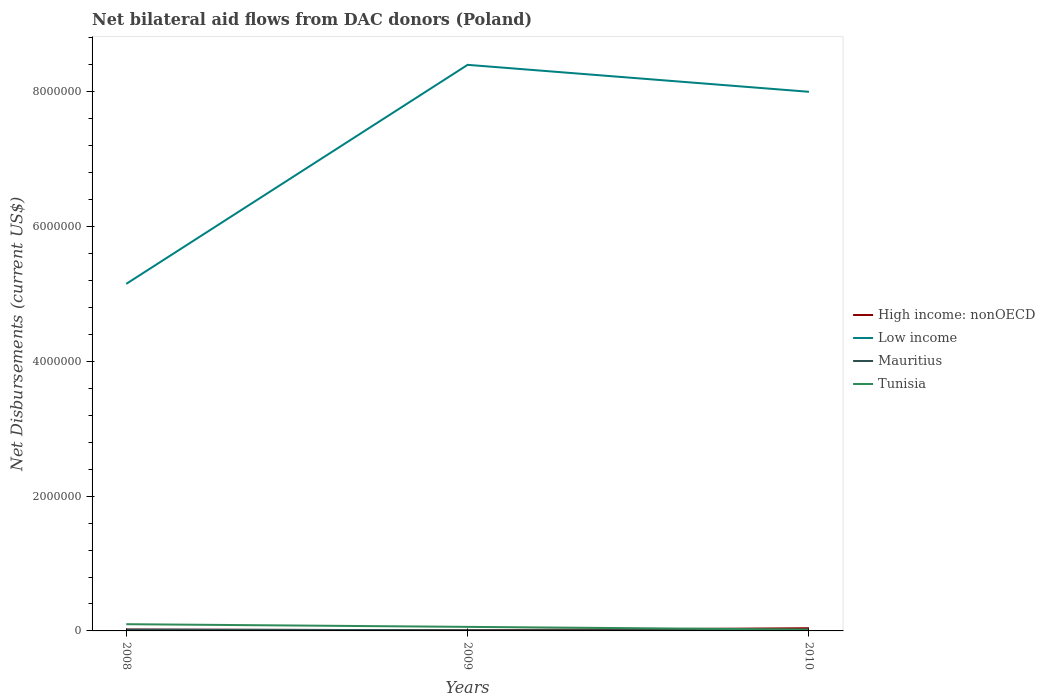Is the number of lines equal to the number of legend labels?
Provide a succinct answer. Yes. Across all years, what is the maximum net bilateral aid flows in Tunisia?
Your answer should be very brief. 2.00e+04. In which year was the net bilateral aid flows in Mauritius maximum?
Make the answer very short. 2009. What is the difference between the highest and the lowest net bilateral aid flows in Low income?
Offer a very short reply. 2. How many lines are there?
Provide a short and direct response. 4. How many years are there in the graph?
Provide a short and direct response. 3. What is the difference between two consecutive major ticks on the Y-axis?
Offer a terse response. 2.00e+06. Are the values on the major ticks of Y-axis written in scientific E-notation?
Give a very brief answer. No. Does the graph contain any zero values?
Your answer should be compact. No. Where does the legend appear in the graph?
Your answer should be very brief. Center right. What is the title of the graph?
Your answer should be compact. Net bilateral aid flows from DAC donors (Poland). What is the label or title of the Y-axis?
Your answer should be compact. Net Disbursements (current US$). What is the Net Disbursements (current US$) of Low income in 2008?
Offer a very short reply. 5.15e+06. What is the Net Disbursements (current US$) in Mauritius in 2008?
Offer a terse response. 2.00e+04. What is the Net Disbursements (current US$) of Tunisia in 2008?
Give a very brief answer. 1.00e+05. What is the Net Disbursements (current US$) in Low income in 2009?
Offer a terse response. 8.40e+06. What is the Net Disbursements (current US$) in Mauritius in 2009?
Provide a short and direct response. 10000. What is the Net Disbursements (current US$) of Tunisia in 2009?
Give a very brief answer. 6.00e+04. What is the Net Disbursements (current US$) in Low income in 2010?
Provide a short and direct response. 8.00e+06. Across all years, what is the maximum Net Disbursements (current US$) in High income: nonOECD?
Your answer should be compact. 4.00e+04. Across all years, what is the maximum Net Disbursements (current US$) in Low income?
Your answer should be very brief. 8.40e+06. Across all years, what is the maximum Net Disbursements (current US$) in Tunisia?
Make the answer very short. 1.00e+05. Across all years, what is the minimum Net Disbursements (current US$) of Low income?
Keep it short and to the point. 5.15e+06. Across all years, what is the minimum Net Disbursements (current US$) of Mauritius?
Your response must be concise. 10000. Across all years, what is the minimum Net Disbursements (current US$) in Tunisia?
Keep it short and to the point. 2.00e+04. What is the total Net Disbursements (current US$) in Low income in the graph?
Provide a succinct answer. 2.16e+07. What is the total Net Disbursements (current US$) of Mauritius in the graph?
Make the answer very short. 4.00e+04. What is the total Net Disbursements (current US$) of Tunisia in the graph?
Make the answer very short. 1.80e+05. What is the difference between the Net Disbursements (current US$) in High income: nonOECD in 2008 and that in 2009?
Offer a terse response. 10000. What is the difference between the Net Disbursements (current US$) in Low income in 2008 and that in 2009?
Provide a succinct answer. -3.25e+06. What is the difference between the Net Disbursements (current US$) of Mauritius in 2008 and that in 2009?
Keep it short and to the point. 10000. What is the difference between the Net Disbursements (current US$) of Tunisia in 2008 and that in 2009?
Ensure brevity in your answer.  4.00e+04. What is the difference between the Net Disbursements (current US$) of Low income in 2008 and that in 2010?
Make the answer very short. -2.85e+06. What is the difference between the Net Disbursements (current US$) in Low income in 2009 and that in 2010?
Your response must be concise. 4.00e+05. What is the difference between the Net Disbursements (current US$) of High income: nonOECD in 2008 and the Net Disbursements (current US$) of Low income in 2009?
Make the answer very short. -8.38e+06. What is the difference between the Net Disbursements (current US$) of High income: nonOECD in 2008 and the Net Disbursements (current US$) of Mauritius in 2009?
Offer a terse response. 10000. What is the difference between the Net Disbursements (current US$) of High income: nonOECD in 2008 and the Net Disbursements (current US$) of Tunisia in 2009?
Offer a terse response. -4.00e+04. What is the difference between the Net Disbursements (current US$) in Low income in 2008 and the Net Disbursements (current US$) in Mauritius in 2009?
Ensure brevity in your answer.  5.14e+06. What is the difference between the Net Disbursements (current US$) in Low income in 2008 and the Net Disbursements (current US$) in Tunisia in 2009?
Offer a terse response. 5.09e+06. What is the difference between the Net Disbursements (current US$) in High income: nonOECD in 2008 and the Net Disbursements (current US$) in Low income in 2010?
Make the answer very short. -7.98e+06. What is the difference between the Net Disbursements (current US$) in High income: nonOECD in 2008 and the Net Disbursements (current US$) in Mauritius in 2010?
Give a very brief answer. 10000. What is the difference between the Net Disbursements (current US$) of High income: nonOECD in 2008 and the Net Disbursements (current US$) of Tunisia in 2010?
Make the answer very short. 0. What is the difference between the Net Disbursements (current US$) of Low income in 2008 and the Net Disbursements (current US$) of Mauritius in 2010?
Your response must be concise. 5.14e+06. What is the difference between the Net Disbursements (current US$) of Low income in 2008 and the Net Disbursements (current US$) of Tunisia in 2010?
Provide a succinct answer. 5.13e+06. What is the difference between the Net Disbursements (current US$) of Mauritius in 2008 and the Net Disbursements (current US$) of Tunisia in 2010?
Give a very brief answer. 0. What is the difference between the Net Disbursements (current US$) of High income: nonOECD in 2009 and the Net Disbursements (current US$) of Low income in 2010?
Provide a succinct answer. -7.99e+06. What is the difference between the Net Disbursements (current US$) in High income: nonOECD in 2009 and the Net Disbursements (current US$) in Mauritius in 2010?
Offer a very short reply. 0. What is the difference between the Net Disbursements (current US$) of Low income in 2009 and the Net Disbursements (current US$) of Mauritius in 2010?
Offer a very short reply. 8.39e+06. What is the difference between the Net Disbursements (current US$) in Low income in 2009 and the Net Disbursements (current US$) in Tunisia in 2010?
Provide a succinct answer. 8.38e+06. What is the difference between the Net Disbursements (current US$) of Mauritius in 2009 and the Net Disbursements (current US$) of Tunisia in 2010?
Provide a succinct answer. -10000. What is the average Net Disbursements (current US$) of High income: nonOECD per year?
Offer a very short reply. 2.33e+04. What is the average Net Disbursements (current US$) of Low income per year?
Make the answer very short. 7.18e+06. What is the average Net Disbursements (current US$) in Mauritius per year?
Your response must be concise. 1.33e+04. In the year 2008, what is the difference between the Net Disbursements (current US$) in High income: nonOECD and Net Disbursements (current US$) in Low income?
Provide a short and direct response. -5.13e+06. In the year 2008, what is the difference between the Net Disbursements (current US$) in Low income and Net Disbursements (current US$) in Mauritius?
Your response must be concise. 5.13e+06. In the year 2008, what is the difference between the Net Disbursements (current US$) in Low income and Net Disbursements (current US$) in Tunisia?
Give a very brief answer. 5.05e+06. In the year 2009, what is the difference between the Net Disbursements (current US$) of High income: nonOECD and Net Disbursements (current US$) of Low income?
Offer a terse response. -8.39e+06. In the year 2009, what is the difference between the Net Disbursements (current US$) in High income: nonOECD and Net Disbursements (current US$) in Mauritius?
Your answer should be compact. 0. In the year 2009, what is the difference between the Net Disbursements (current US$) of Low income and Net Disbursements (current US$) of Mauritius?
Your response must be concise. 8.39e+06. In the year 2009, what is the difference between the Net Disbursements (current US$) in Low income and Net Disbursements (current US$) in Tunisia?
Your answer should be very brief. 8.34e+06. In the year 2010, what is the difference between the Net Disbursements (current US$) of High income: nonOECD and Net Disbursements (current US$) of Low income?
Your response must be concise. -7.96e+06. In the year 2010, what is the difference between the Net Disbursements (current US$) of High income: nonOECD and Net Disbursements (current US$) of Mauritius?
Your answer should be very brief. 3.00e+04. In the year 2010, what is the difference between the Net Disbursements (current US$) of Low income and Net Disbursements (current US$) of Mauritius?
Keep it short and to the point. 7.99e+06. In the year 2010, what is the difference between the Net Disbursements (current US$) in Low income and Net Disbursements (current US$) in Tunisia?
Your answer should be very brief. 7.98e+06. In the year 2010, what is the difference between the Net Disbursements (current US$) in Mauritius and Net Disbursements (current US$) in Tunisia?
Your answer should be very brief. -10000. What is the ratio of the Net Disbursements (current US$) of Low income in 2008 to that in 2009?
Your answer should be compact. 0.61. What is the ratio of the Net Disbursements (current US$) of Tunisia in 2008 to that in 2009?
Give a very brief answer. 1.67. What is the ratio of the Net Disbursements (current US$) of Low income in 2008 to that in 2010?
Make the answer very short. 0.64. What is the ratio of the Net Disbursements (current US$) of Tunisia in 2008 to that in 2010?
Ensure brevity in your answer.  5. What is the ratio of the Net Disbursements (current US$) in High income: nonOECD in 2009 to that in 2010?
Offer a very short reply. 0.25. What is the ratio of the Net Disbursements (current US$) of Tunisia in 2009 to that in 2010?
Ensure brevity in your answer.  3. What is the difference between the highest and the second highest Net Disbursements (current US$) in Low income?
Your answer should be compact. 4.00e+05. What is the difference between the highest and the second highest Net Disbursements (current US$) of Mauritius?
Give a very brief answer. 10000. What is the difference between the highest and the lowest Net Disbursements (current US$) in High income: nonOECD?
Offer a very short reply. 3.00e+04. What is the difference between the highest and the lowest Net Disbursements (current US$) of Low income?
Keep it short and to the point. 3.25e+06. What is the difference between the highest and the lowest Net Disbursements (current US$) in Tunisia?
Give a very brief answer. 8.00e+04. 